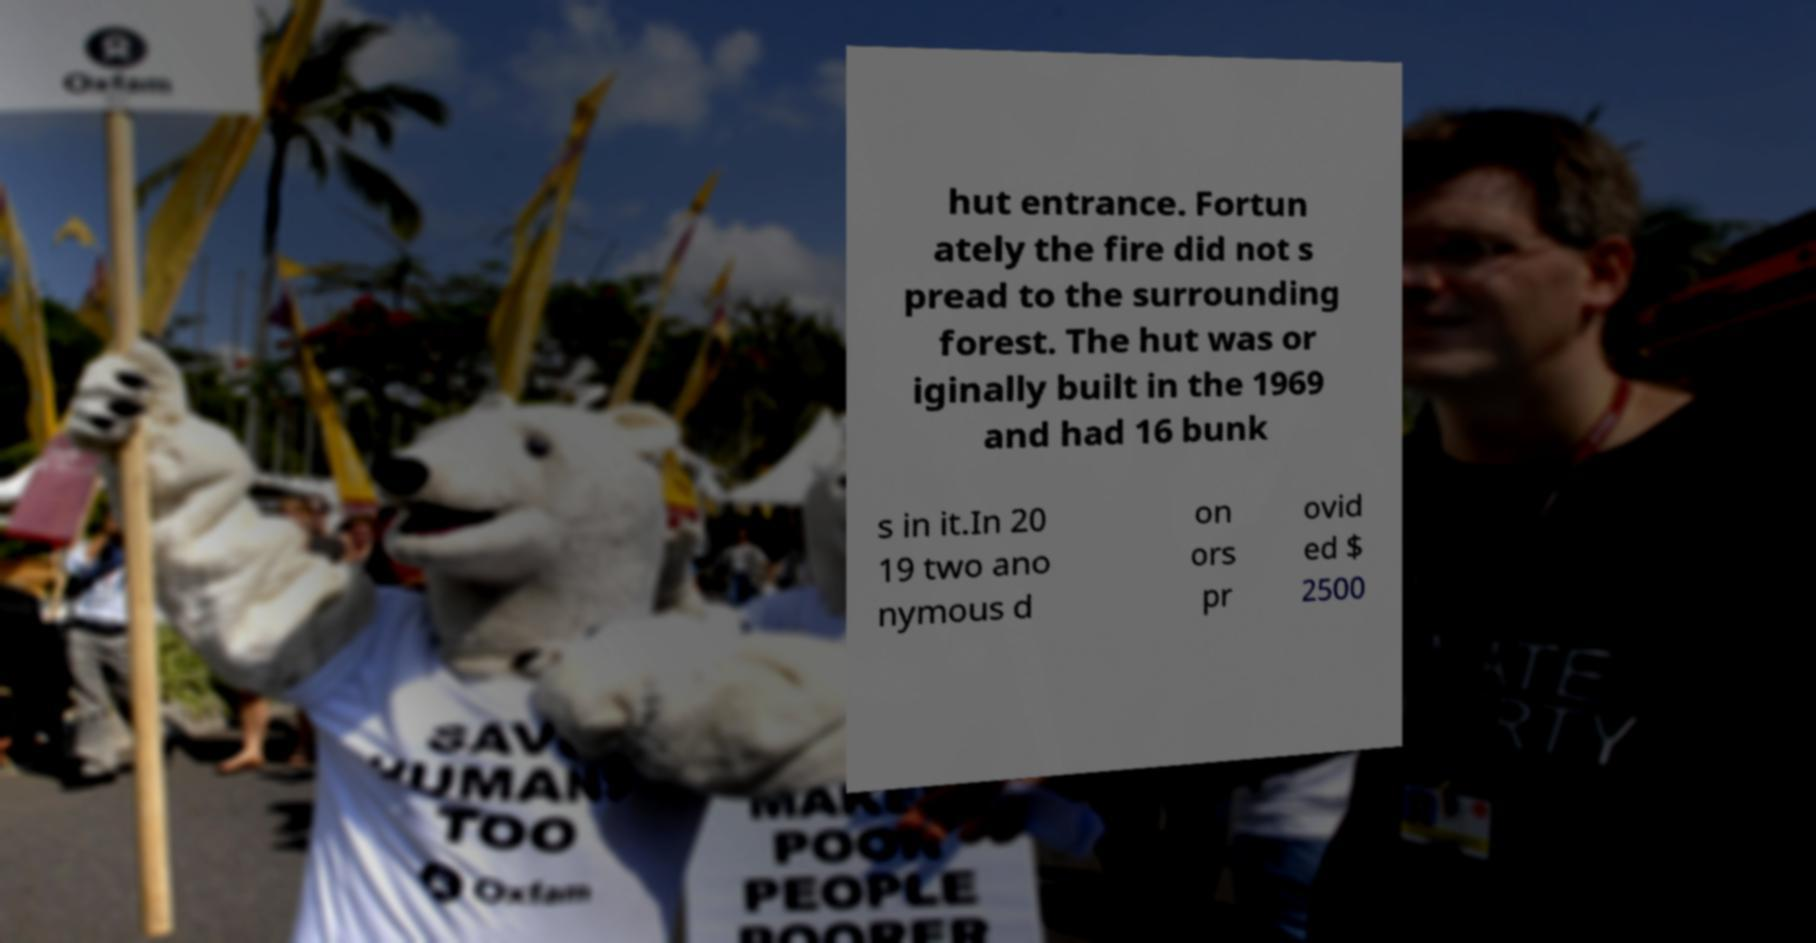Can you accurately transcribe the text from the provided image for me? hut entrance. Fortun ately the fire did not s pread to the surrounding forest. The hut was or iginally built in the 1969 and had 16 bunk s in it.In 20 19 two ano nymous d on ors pr ovid ed $ 2500 